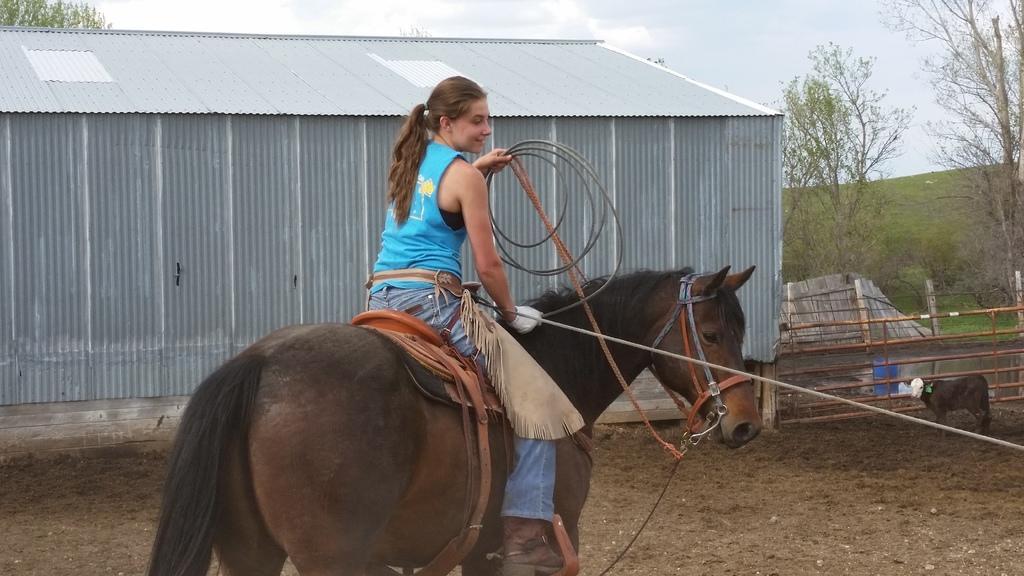How would you summarize this image in a sentence or two? In this image in the front there is a woman sitting on the horse and holding a rope in her hand. In the background there are trees, there is grass on the ground, there is a fence and there is a cottage and the sky is cloudy and there is an animal. 